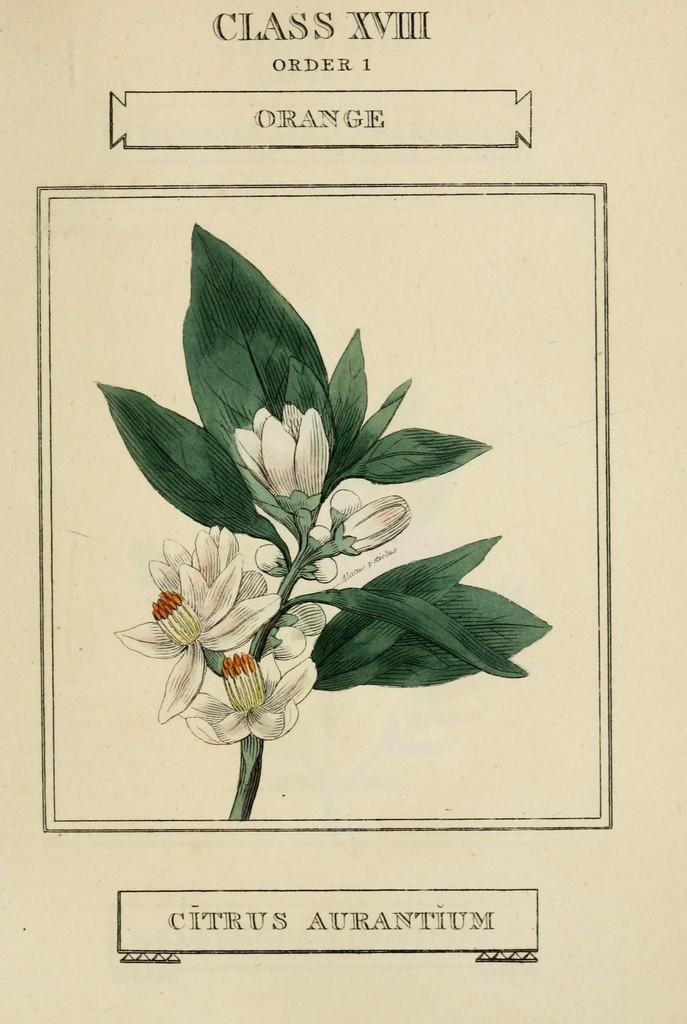What is depicted in the image? There is a sketch of flowers and a sketch of leaves in the image. What medium is used for the sketches? The sketches are on a piece of paper. In which direction are the flowers facing in the image? The flowers are not facing a specific direction, as they are a sketch on a piece of paper and do not have a physical orientation. 